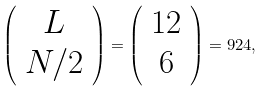<formula> <loc_0><loc_0><loc_500><loc_500>\left ( \begin{array} { c } L \\ N / 2 \end{array} \right ) = \left ( \begin{array} { c } 1 2 \\ 6 \end{array} \right ) = 9 2 4 ,</formula> 